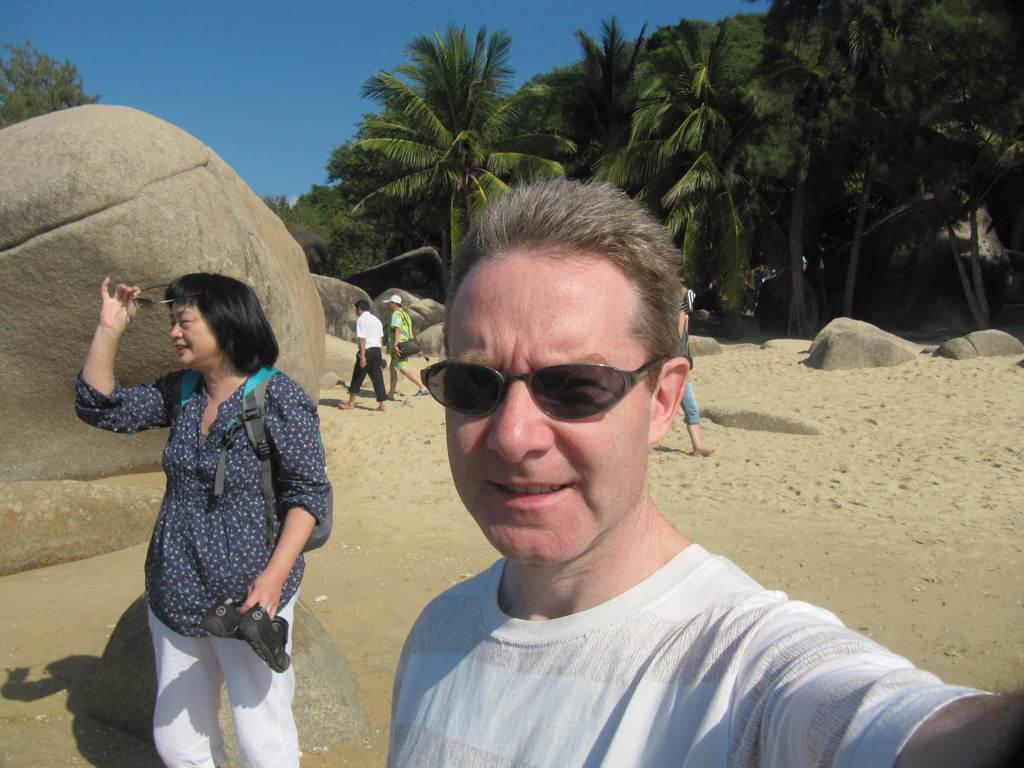Could you give a brief overview of what you see in this image? In the image we can see there are people standing on the ground and there is sand on the ground. The man is wearing sunglasses and the woman is holding shoes in her hand. There is a rock hill and behind there are lot of trees. 